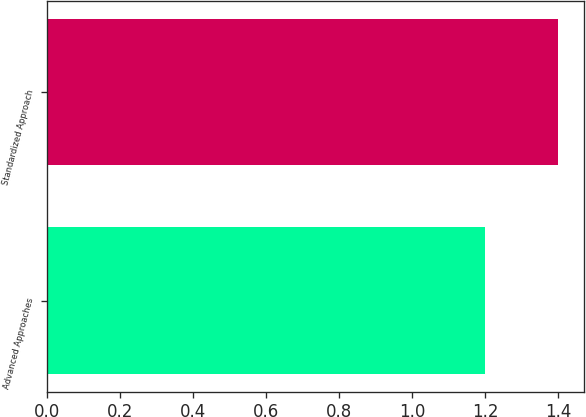Convert chart. <chart><loc_0><loc_0><loc_500><loc_500><bar_chart><fcel>Advanced Approaches<fcel>Standardized Approach<nl><fcel>1.2<fcel>1.4<nl></chart> 